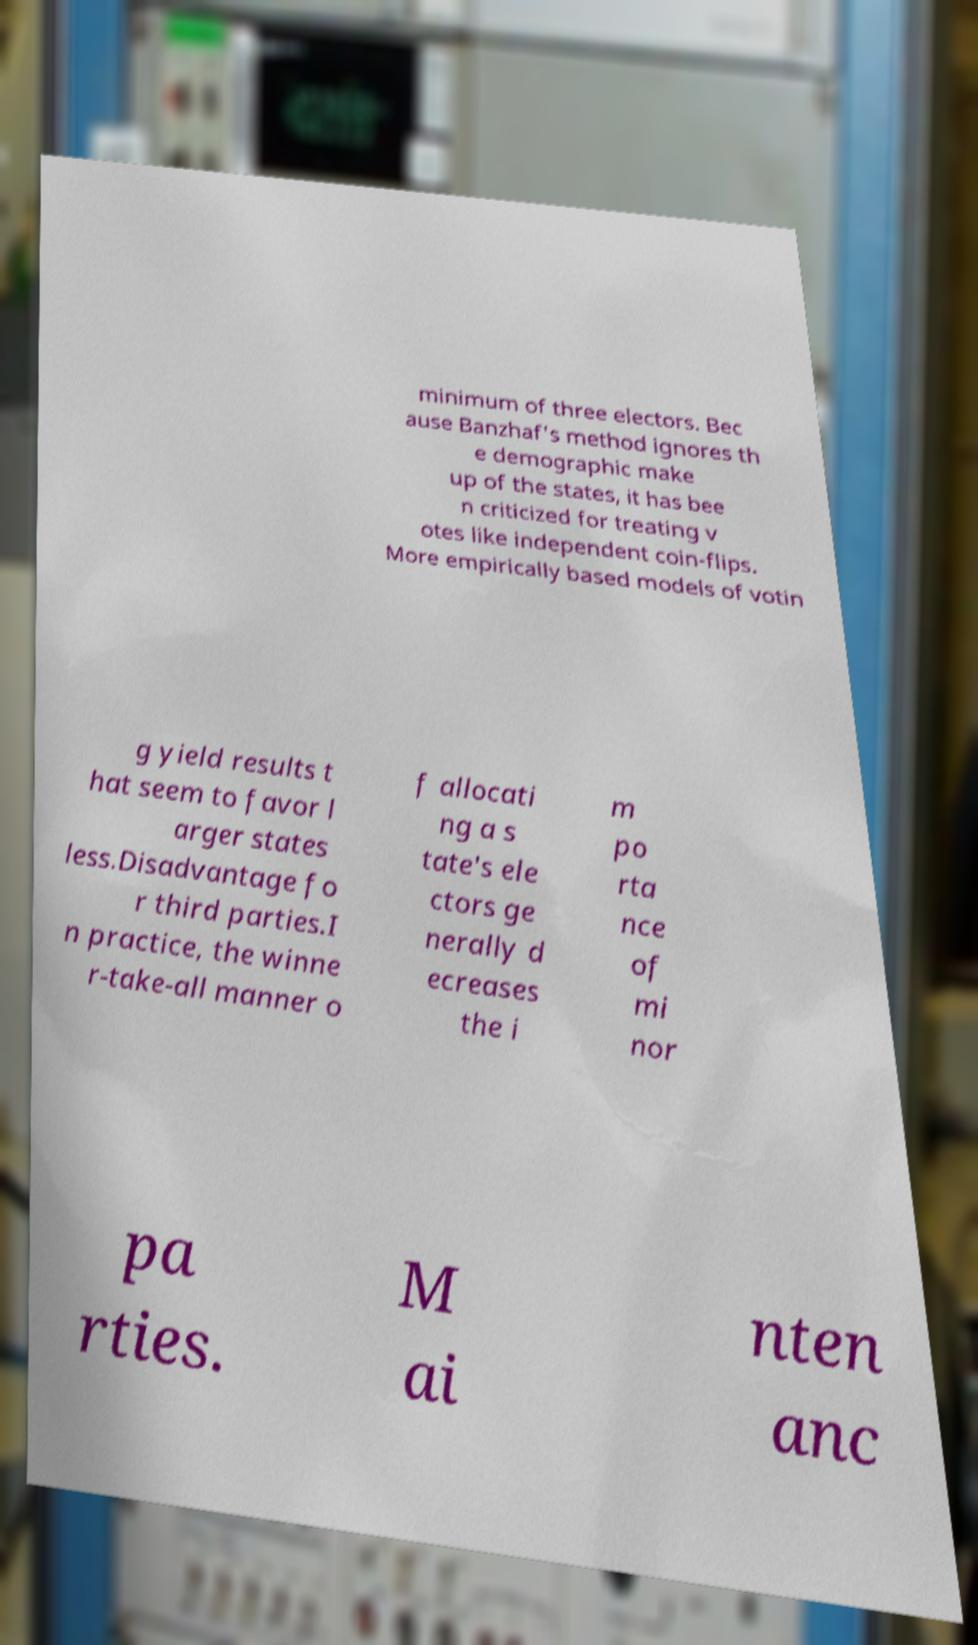Please read and relay the text visible in this image. What does it say? minimum of three electors. Bec ause Banzhaf's method ignores th e demographic make up of the states, it has bee n criticized for treating v otes like independent coin-flips. More empirically based models of votin g yield results t hat seem to favor l arger states less.Disadvantage fo r third parties.I n practice, the winne r-take-all manner o f allocati ng a s tate's ele ctors ge nerally d ecreases the i m po rta nce of mi nor pa rties. M ai nten anc 